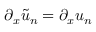<formula> <loc_0><loc_0><loc_500><loc_500>\partial _ { x } \tilde { u } _ { n } = \partial _ { x } u _ { n }</formula> 